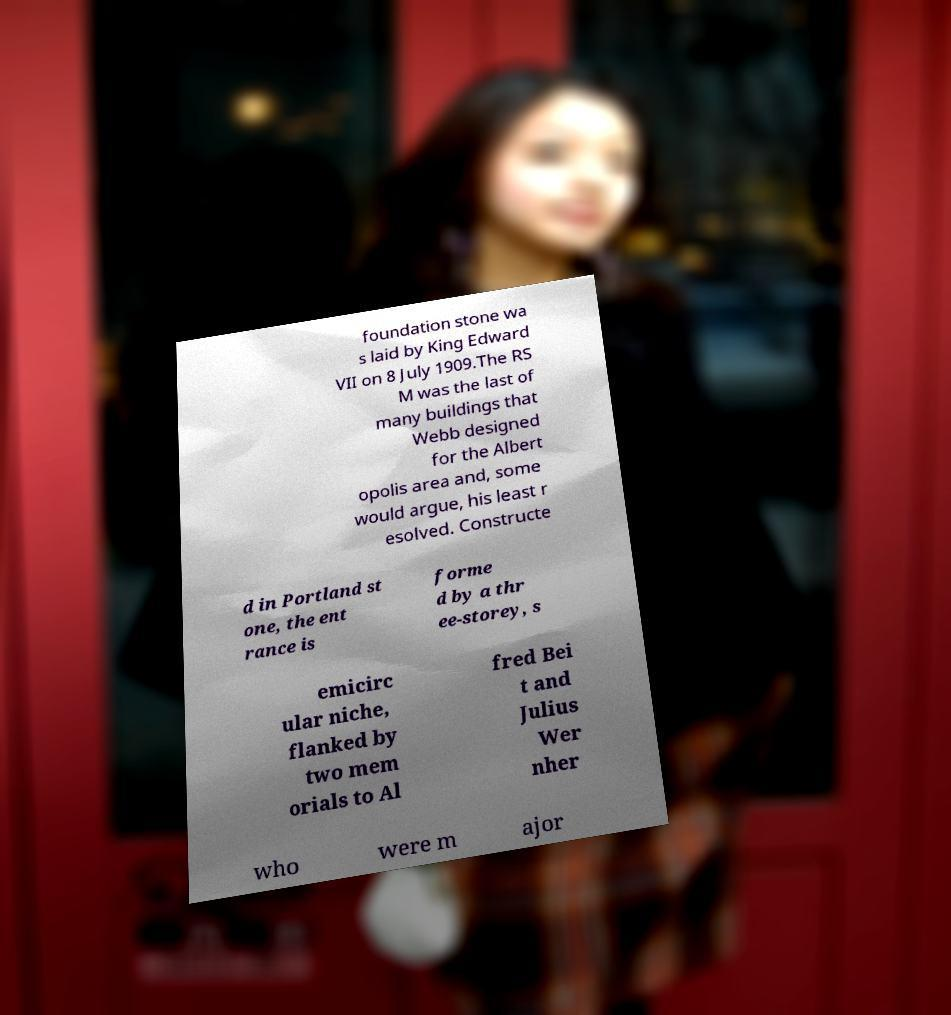There's text embedded in this image that I need extracted. Can you transcribe it verbatim? foundation stone wa s laid by King Edward VII on 8 July 1909.The RS M was the last of many buildings that Webb designed for the Albert opolis area and, some would argue, his least r esolved. Constructe d in Portland st one, the ent rance is forme d by a thr ee-storey, s emicirc ular niche, flanked by two mem orials to Al fred Bei t and Julius Wer nher who were m ajor 